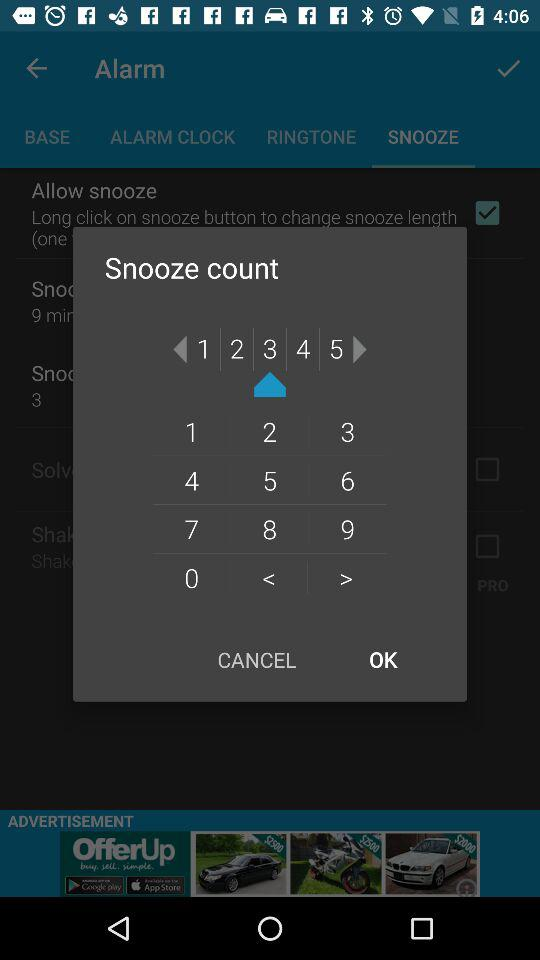What is the status of "Allow snooze"? The status of "Allow snooze" is "on". 